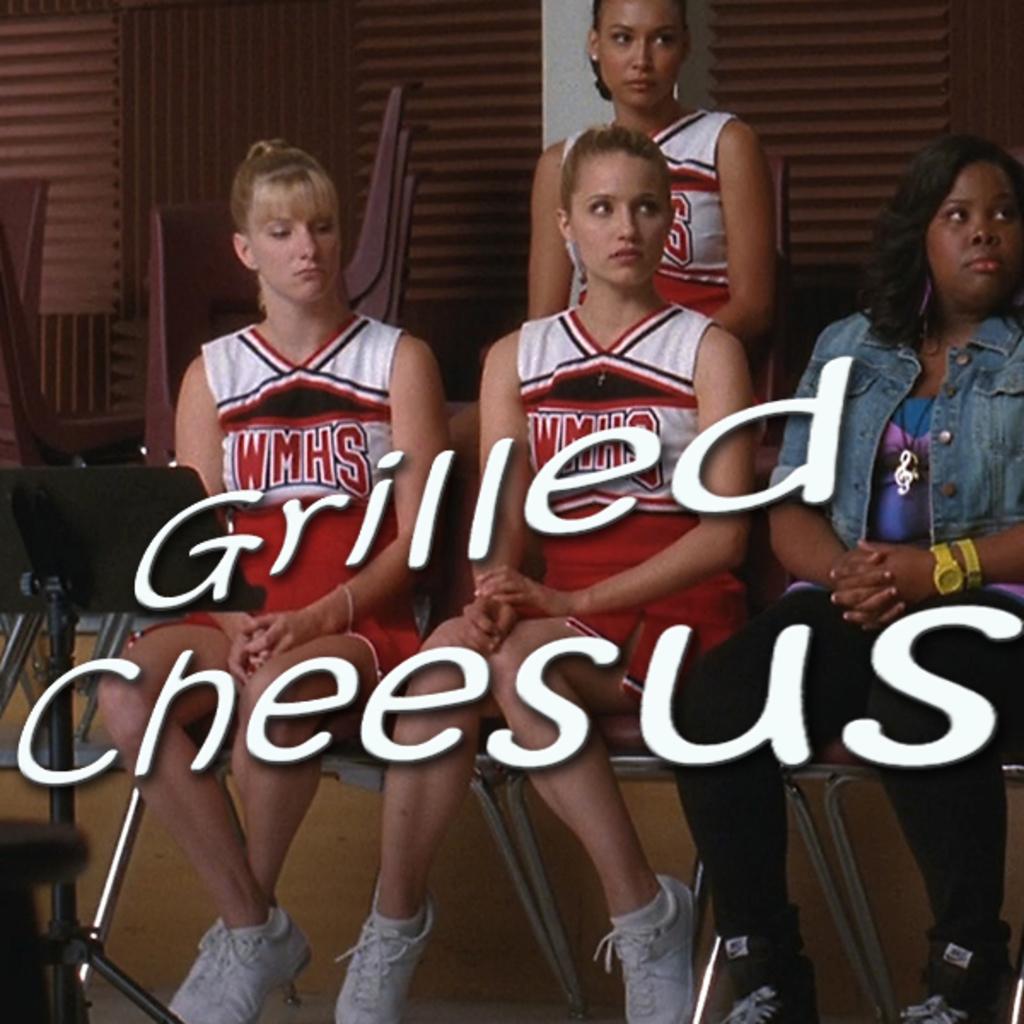What team are the cheerleaders cheering for?
Your answer should be compact. Wmhs. What is grilled?
Make the answer very short. Cheesus. 